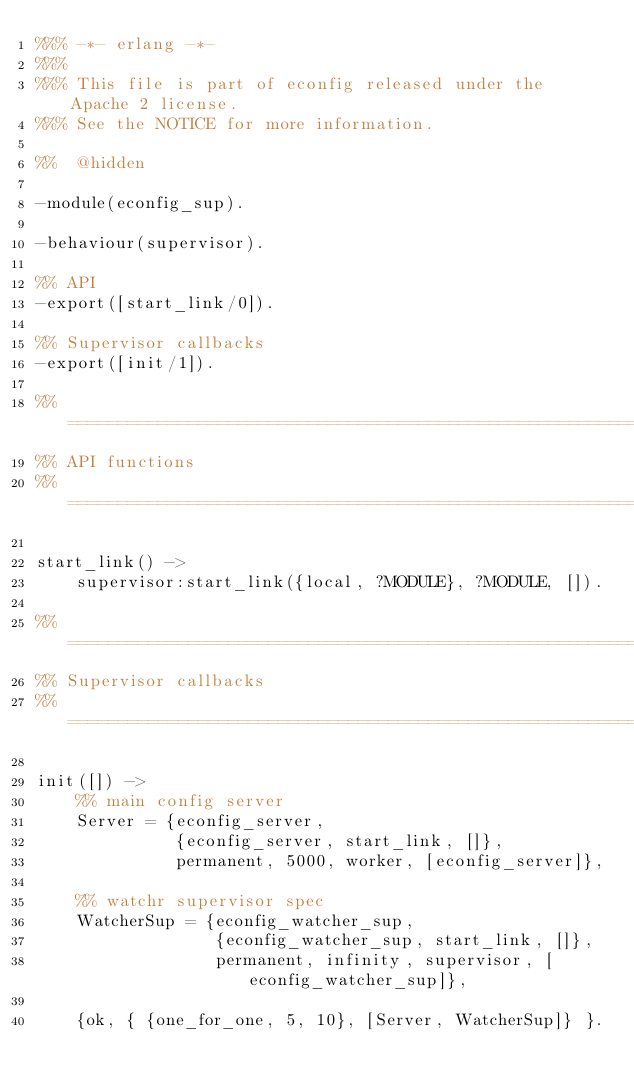<code> <loc_0><loc_0><loc_500><loc_500><_Erlang_>%%% -*- erlang -*-
%%%
%%% This file is part of econfig released under the Apache 2 license.
%%% See the NOTICE for more information.

%%  @hidden

-module(econfig_sup).

-behaviour(supervisor).

%% API
-export([start_link/0]).

%% Supervisor callbacks
-export([init/1]).

%% ===================================================================
%% API functions
%% ===================================================================

start_link() ->
    supervisor:start_link({local, ?MODULE}, ?MODULE, []).

%% ===================================================================
%% Supervisor callbacks
%% ===================================================================

init([]) ->
    %% main config server
    Server = {econfig_server,
              {econfig_server, start_link, []},
              permanent, 5000, worker, [econfig_server]},

    %% watchr supervisor spec
    WatcherSup = {econfig_watcher_sup,
                  {econfig_watcher_sup, start_link, []},
                  permanent, infinity, supervisor, [econfig_watcher_sup]},

    {ok, { {one_for_one, 5, 10}, [Server, WatcherSup]} }.

</code> 